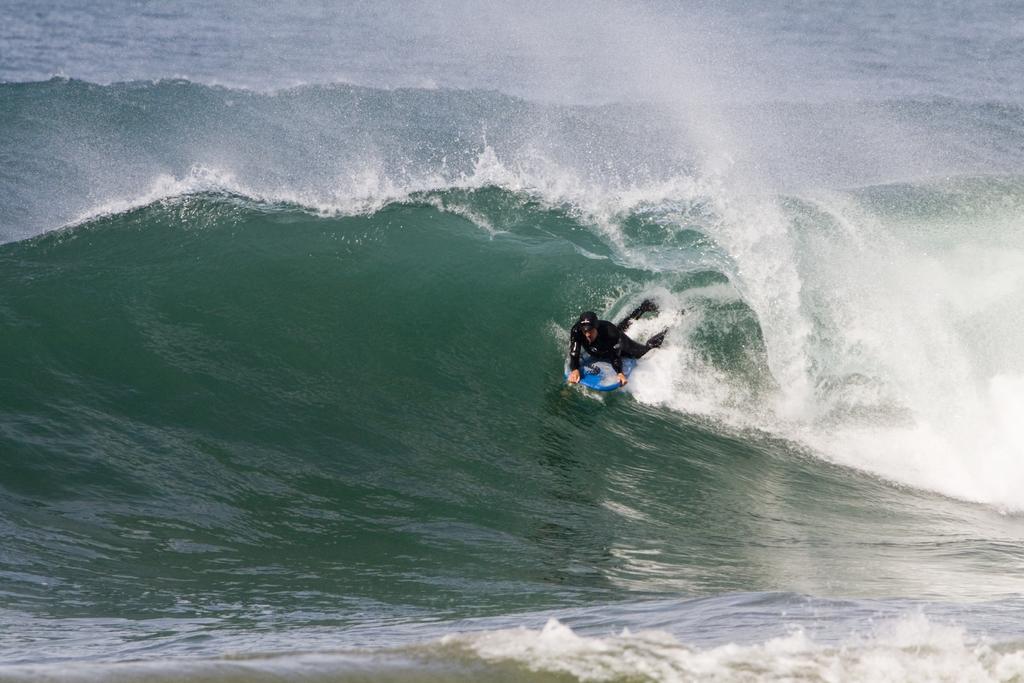Describe this image in one or two sentences. In this picture we can see a man wearing a swimming suit and lying on a surfboard and surfing on the water. 